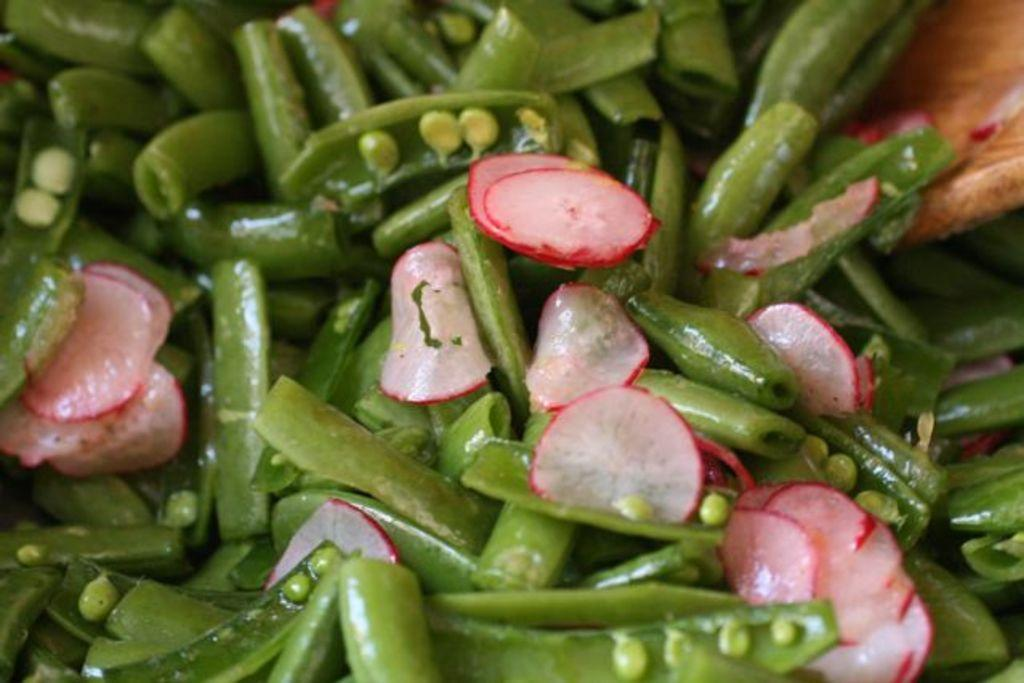What type of vegetables can be seen in the image? There are sliced radish and green beans in the image. Can you describe the wooden object in the image? There is a wooden object in the top right corner of the image. What type of teeth can be seen in the image? There are no teeth visible in the image. Is there a birthday celebration happening in the image? There is no indication of a birthday celebration in the image. 